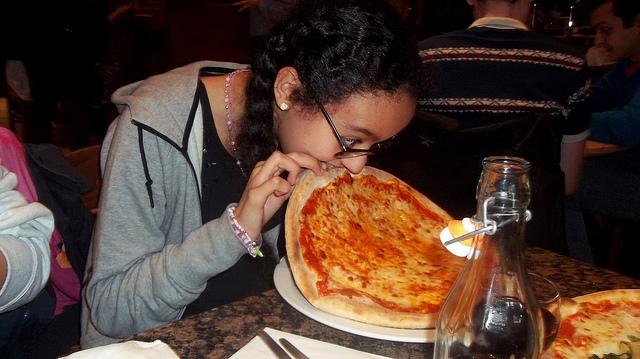What type of hair style does this person have?
Keep it brief. Braid. What is the table made out of?
Write a very short answer. Marble. Is the girl wearing a bracelet?
Be succinct. Yes. What is this girl eating?
Answer briefly. Pizza. Is this woman blowing her nose, caught in food, or trying to hide?
Keep it brief. Caught in food. 